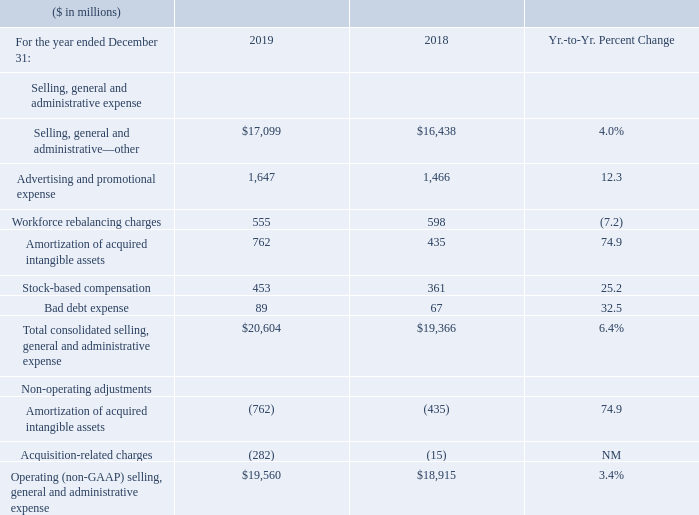Selling, General and Administrative Expense
NM—Not meaningful
Total selling, general and administrative (SG&A) expense increased 6.4 percent in 2019 versus 2018, driven primarily by the following factors: • Higher spending (5 points) driven by Red Hat spending (5 points); and • Higher acquisition-related charges and amortization of acquired intangible assets associated with the Red Hat acquisition (3 points); partially offset by • The effects of currency (2 points).
Operating (non-GAAP) expense increased 3.4 percent year to year primarily driven by the same factors excluding the acquisition-related charges and amortization of acquired intangible assets associated with the Red Hat transaction.
What caused the Total selling, general and administrative (SG&A) expense to increase? Higher spending (5 points) driven by red hat spending (5 points); and • higher acquisition-related charges and amortization of acquired intangible assets associated with the red hat acquisition (3 points); partially offset by • the effects of currency (2 points). What caused the Operating (non-GAAP) expense to increase? Driven by the same factors excluding the acquisition-related charges and amortization of acquired intangible assets associated with the red hat transaction. What were the Bad debt expenses in 2019?
Answer scale should be: million. 89. What was the increase / (decrease) in the Selling, general and administrative—other from 2018 to 2019?
Answer scale should be: million. 17,099 - 16,438
Answer: 661. What was the average of Advertising and promotional expense?
Answer scale should be: million. (1,647 + 1,466) / 2
Answer: 1556.5. What is the increase / (decrease) in the Stock-based compensation from 2018 to 2019?
Answer scale should be: million. 453 - 361
Answer: 92. 